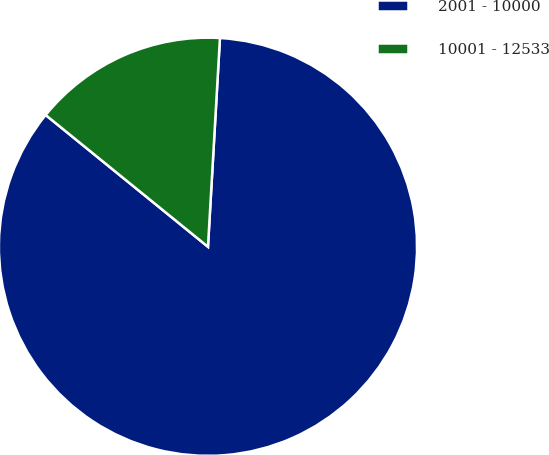<chart> <loc_0><loc_0><loc_500><loc_500><pie_chart><fcel>2001 - 10000<fcel>10001 - 12533<nl><fcel>84.94%<fcel>15.06%<nl></chart> 